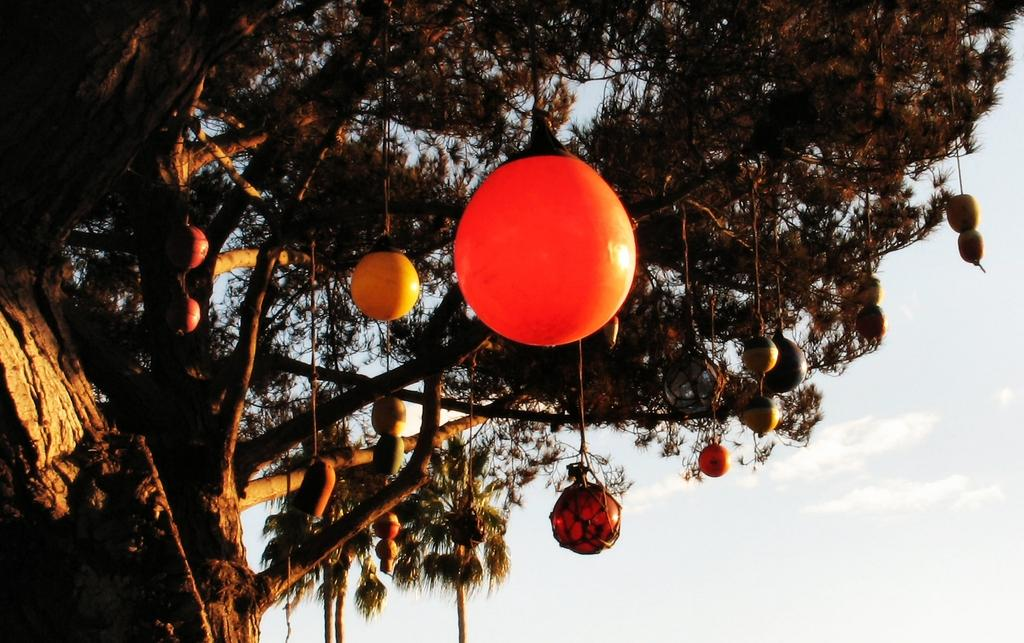What is hanging from the tree in the image? There are objects hanging from a tree in the image. How are the objects attached to the tree? The objects are tied with ropes. What can be seen in the background of the image? There are trees and the sky visible in the background of the image. What is the condition of the sky in the image? The sky appears cloudy in the image. What type of pen is being used to write on the tree in the image? There is no pen or writing present on the tree in the image. What type of apparel is being worn by the tree in the image? Trees do not wear apparel, as they are plants and not people. 